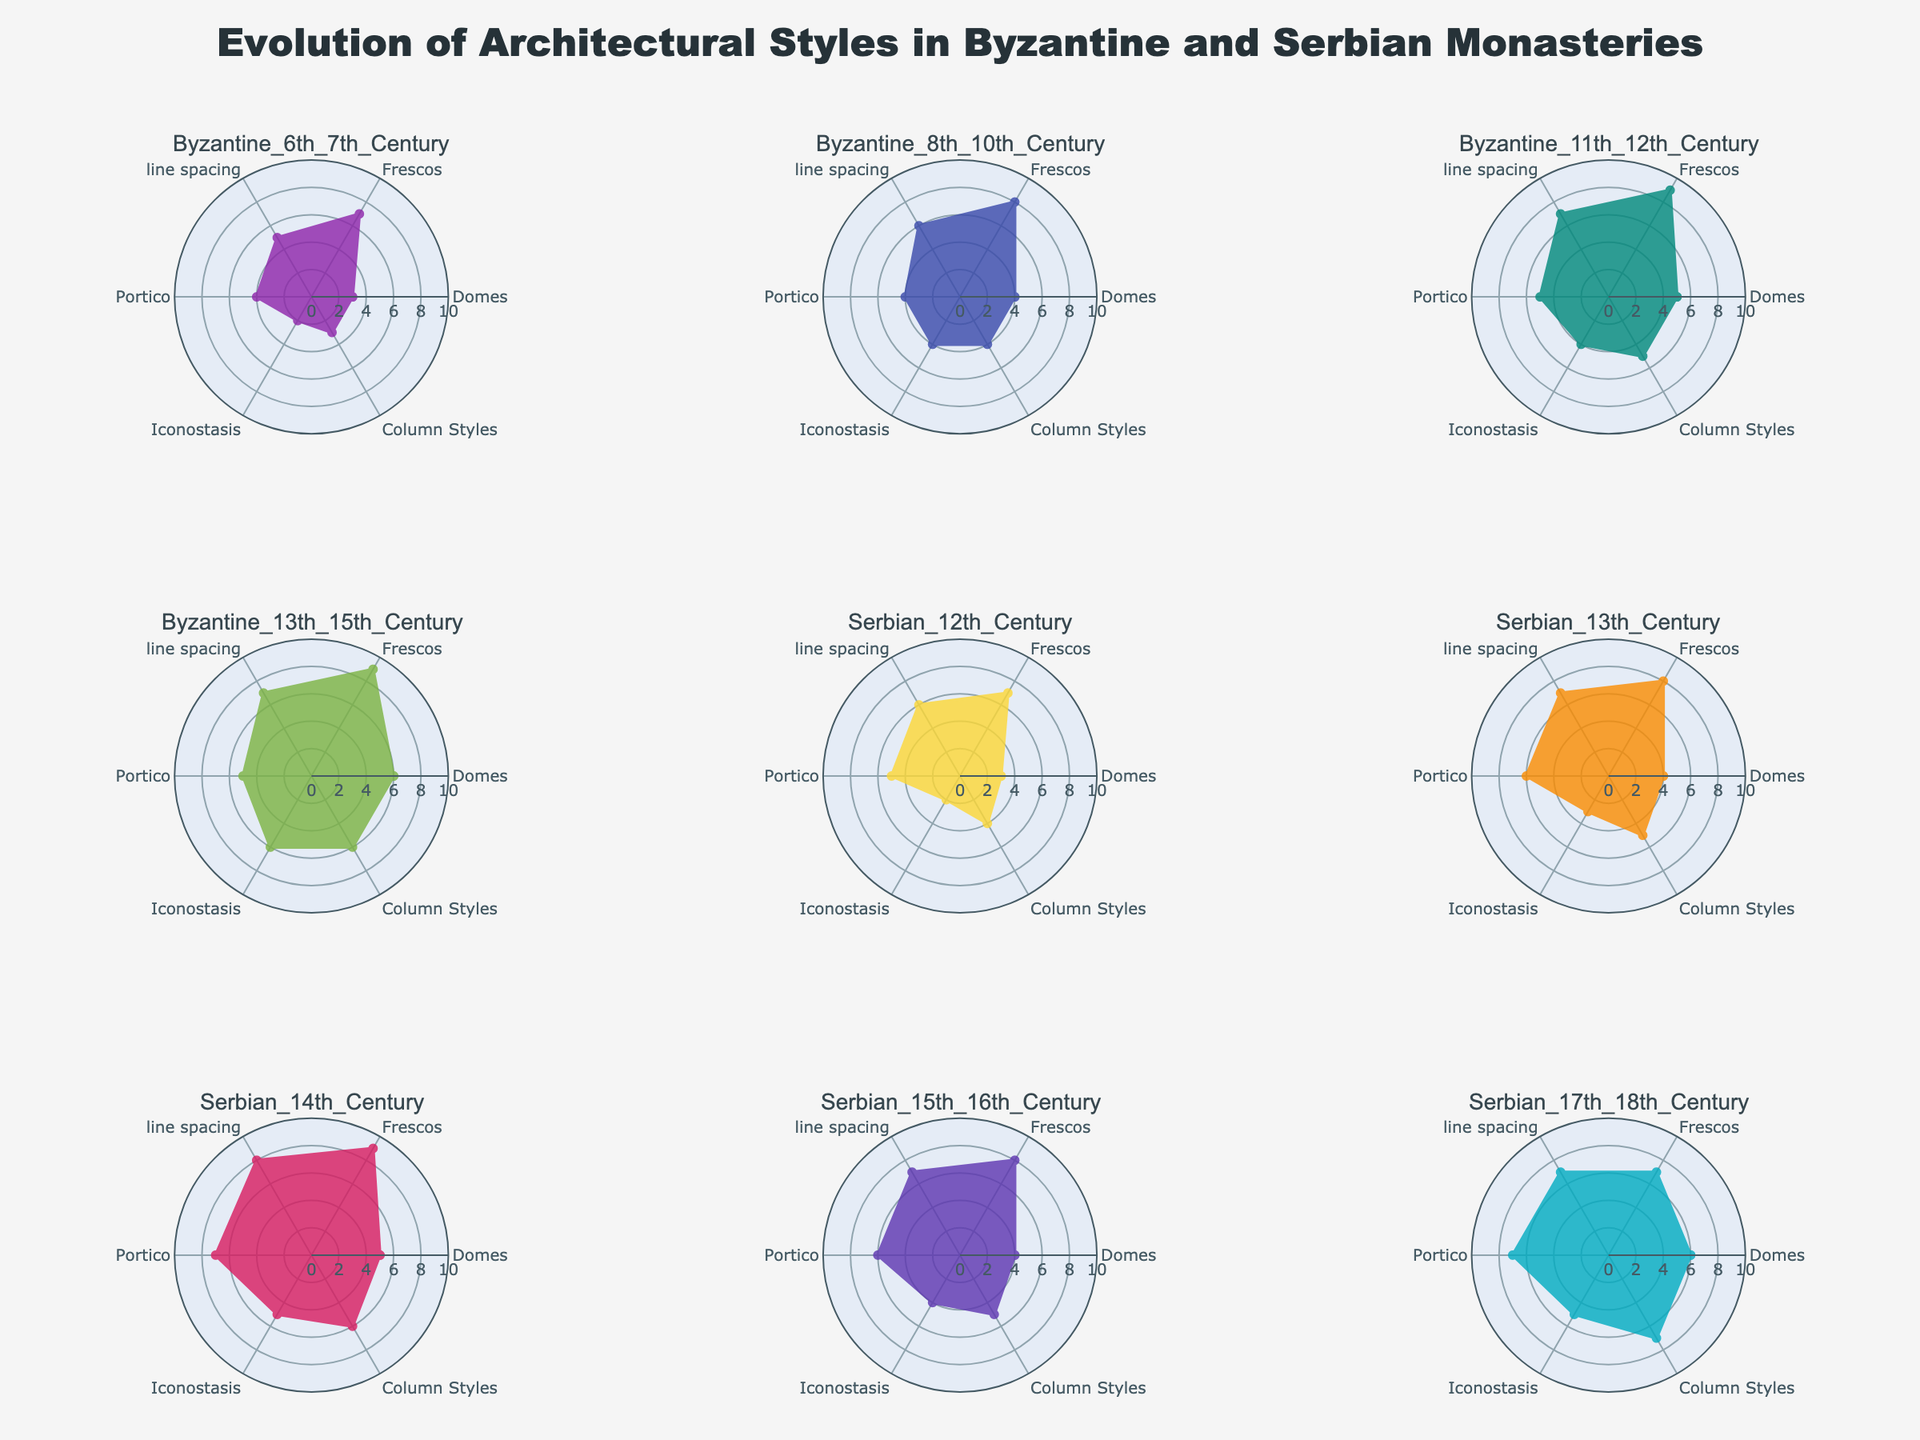what is the total number of periods compared in the figure? By counting the total number of subplot titles in the figure, we see Byzantium periods (6th-15th century) and Serbian periods (12th-18th century). Summing them up gives us 5 Byzantine periods and 5 Serbian periods, making the total number of periods compared 10.
Answer: 10 which period has the most number of domes? To identify this, we analyze each subplot for the `Domes` category and find the period with the highest value. The `Domes` category ranges from 3 to 6 for Byzantine periods and 3 to 6 for Serbian periods. The `Baroque Influences` (Serbian 17th-18th Century) has the highest value of 'Domes'.
Answer: Baroque Influences how do the fresco levels compare between Byzantine 11th_12th Century and Serbian 14th Century? In the radar charts of both periods, check the value corresponding to `Frescos`. `Komnenian Byzantine` (11th-12th Century) has a frescos value of 9, and `Serbo-Byzantine Style` (14th Century) also has a frescos value of 9. Thus, both periods have equal levels of frescos.
Answer: Equal levels for which period is the 'Portico' value the highest? This involves checking the values under Portico for each subplot. The period `Serbo-Byzantine Style` (Serbian 14th Century) has a `Portico` value of 7, which is the highest among all periods shown.
Answer: Serbo-Byzantine Style what is the average value of the 'Frescos' category across all Byzantine periods? To find this, sum the values for the `Frescos` category across all Byzantine periods: 7 (Early Byzantine Basilica) + 8 (Middle Byzantine) + 9 (Komnenian Byzantine) + 9 (Palaeologan Renaissance) = 33. The average is 33/4 (since there are 4 Byzantine periods considered), which equals 8.25.
Answer: 8.25 which period shows the most balanced architecture, i.e., has the most similar values across all categories? Analyzing each radar plot, `Palaeologan Renaissance` (Byzantine 13th-15th Century) and `Serbo-Byzantine Style` (Serbian 14th Century) appear more balanced with minimal spread among different categories range between 5 and 7. Both show similar values across the attributes compared.
Answer: Palaeologan Renaissance, Serbo-Byzantine Style how does the `Column Styles` development differ between Byzantine 8th_10th Century and Serbian 15th_16th Century? By comparing the radar charts, `Middle Byzantine` (8th-10th Century) has a value of 4 in `Column Styles`, while `Morenča School` (Serbian 15th-16th Century) displays a value of 5. This indicates a slight development or increase in `Column Styles` from the Byzantine to the Serbian period.
Answer: Serbian 15th-16th Century has a higher development which period has the lowest overall architectural scores? By visually inspecting each radar plot, `Early Byzantine Basilica` (6th-7th Century) appears to have generally lower values across most categories (Domes 3, Frescos 7, etc.). Hence, the Early Byzantine Basilica period has the lowest scores overall.
Answer: Early Byzantine Basilica 